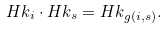<formula> <loc_0><loc_0><loc_500><loc_500>H k _ { i } \cdot H k _ { s } = H k _ { g ( i , s ) } .</formula> 